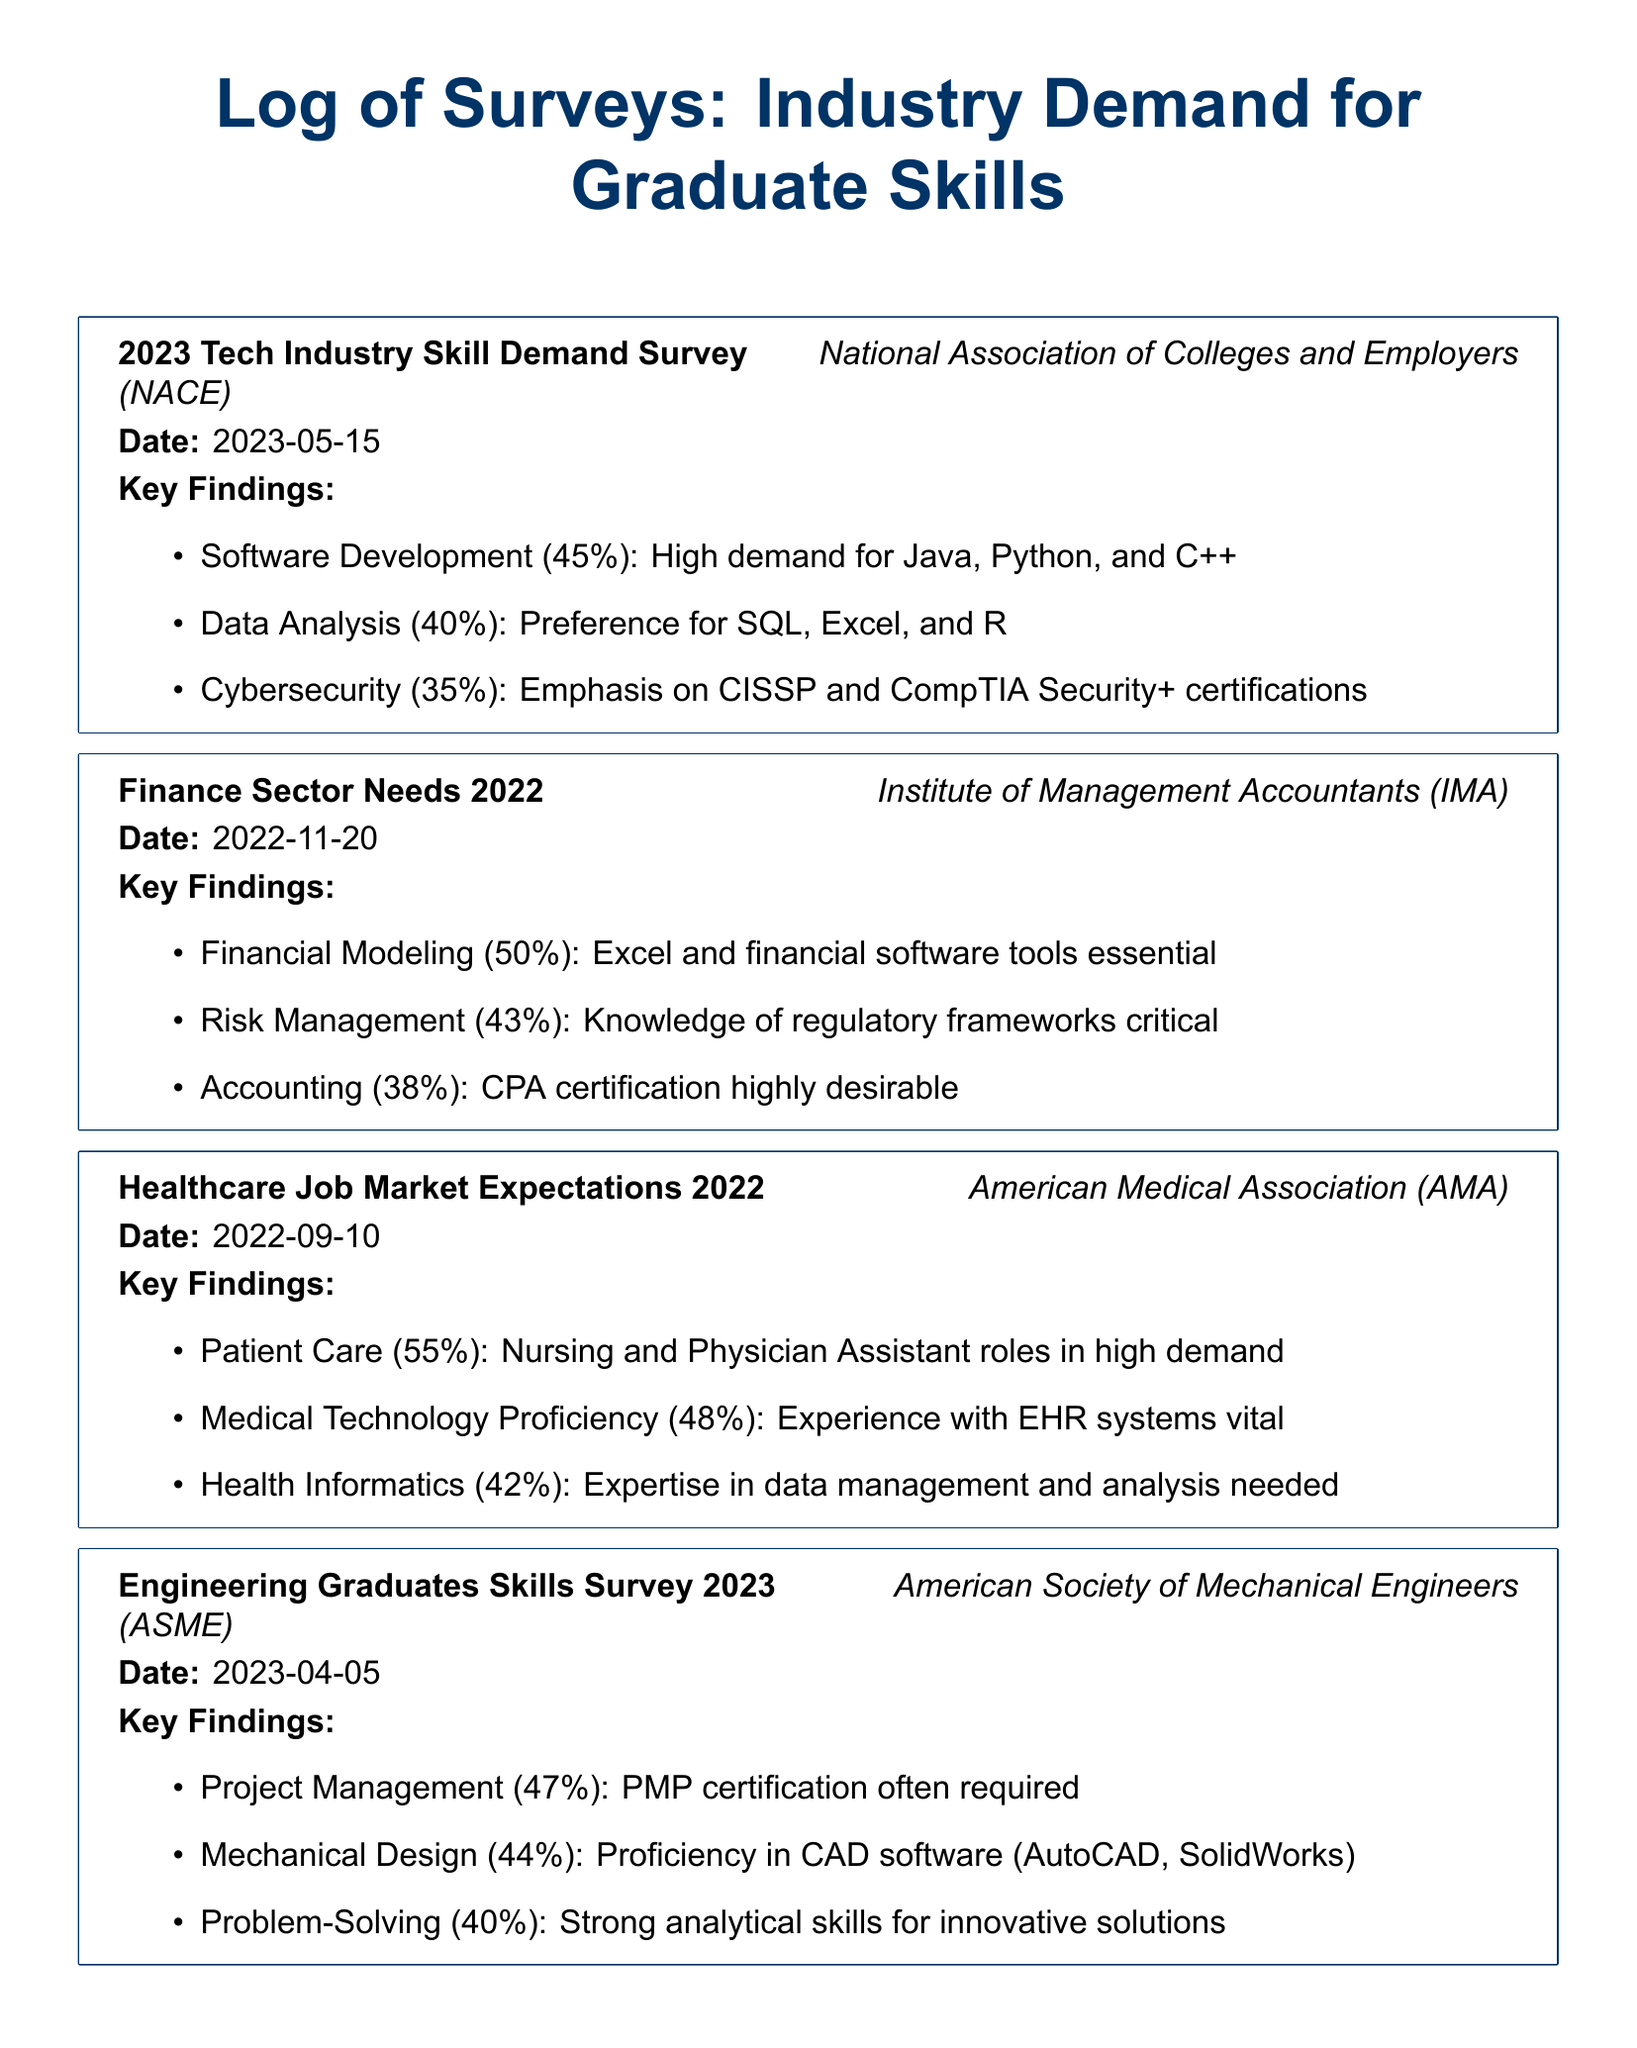What organization conducted the 2023 Tech Industry Skill Demand Survey? The organization that conducted the survey is mentioned at the start of the entry, which is the National Association of Colleges and Employers (NACE).
Answer: National Association of Colleges and Employers (NACE) What percentage of demand is there for Software Development skills according to the 2023 survey? The percentage for Software Development is specified in the Key Findings of the survey entry, which states 45%.
Answer: 45% What key skill is emphasized in the Healthcare Job Market Expectations survey? The key skill that is highlighted is based on the findings in the log entry, specifically the focus on Patient Care.
Answer: Patient Care Which certification is highly desirable in the Finance Sector Needs survey? The certification that is noted as highly desirable is clearly stated in the findings, which is CPA certification.
Answer: CPA certification What date was the Engineering Graduates Skills Survey conducted? The date for the Engineering Graduates Skills Survey is provided in the survey entry details, which is April 5, 2023.
Answer: 2023-04-05 Which two software proficiencies are important for Mechanical Design? The proficiencies are mentioned in the findings, specifically naming AutoCAD and SolidWorks.
Answer: AutoCAD, SolidWorks Which industry shows a 55% demand for skills in Patient Care? The industry is indicated in the findings section that focuses on demand in the Healthcare job market.
Answer: Healthcare What is the overall theme of the document? The theme of the document revolves around surveying industry demand for skills required in recent graduates across various sectors.
Answer: Industry demand for graduate skills 